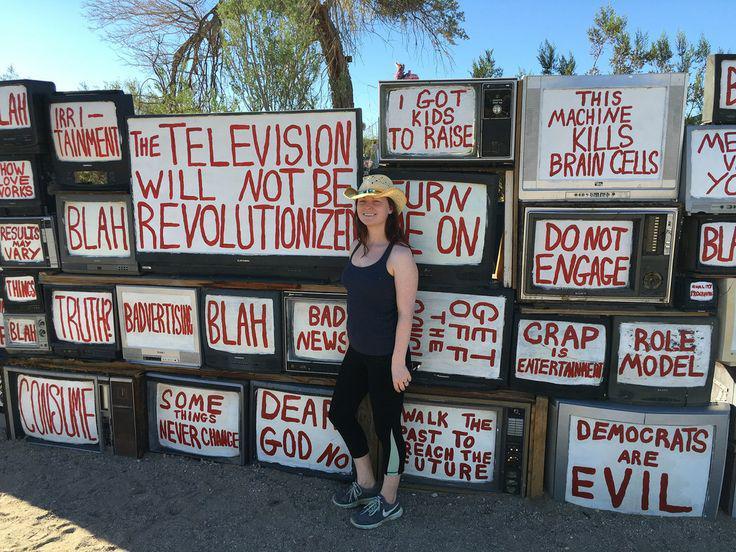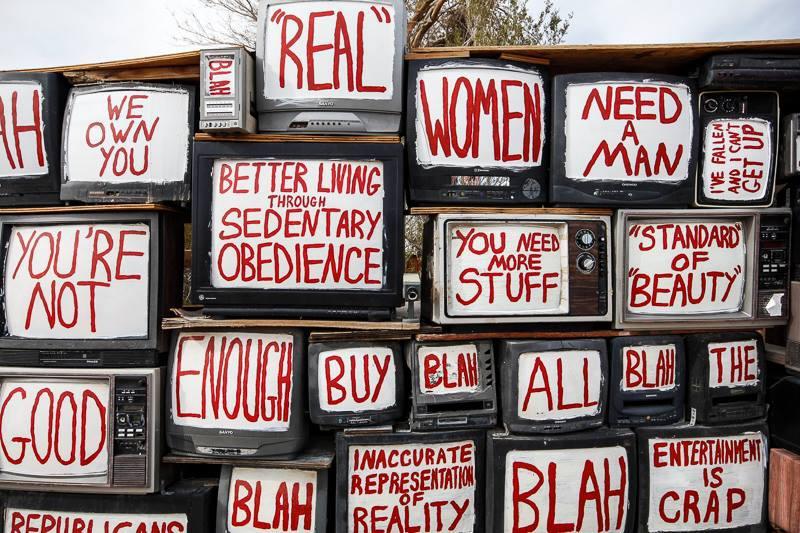The first image is the image on the left, the second image is the image on the right. Examine the images to the left and right. Is the description "in at least on of the pics, the sign that says the television will not be revolutionized is the highest sign in the photo" accurate? Answer yes or no. No. The first image is the image on the left, the second image is the image on the right. Assess this claim about the two images: "A screen in the lower right says that democrats are evil, in at least one of the images.". Correct or not? Answer yes or no. Yes. 